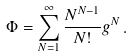<formula> <loc_0><loc_0><loc_500><loc_500>\Phi = \sum _ { N = 1 } ^ { \infty } \frac { N ^ { N - 1 } } { N ! } g ^ { N } \, .</formula> 